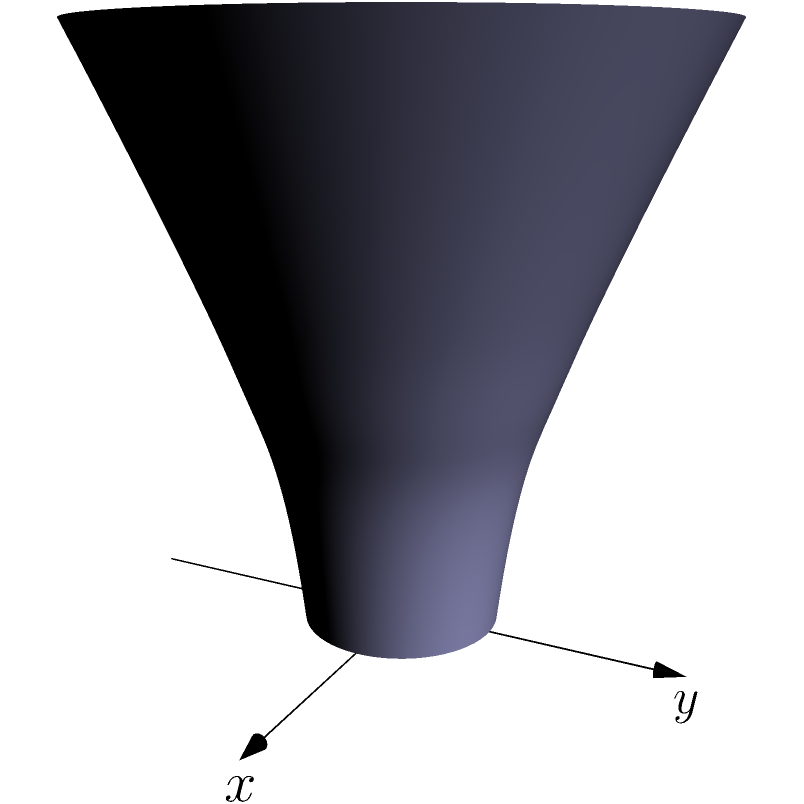Consider the hyperbola $\frac{x^2}{a^2} - \frac{z^2}{b^2} = 1$ in the xz-plane, where $a$ and $b$ are positive constants. When this hyperbola is rotated around the z-axis (its transverse axis), it generates a three-dimensional shape. What is the name of this resulting shape, and what is its equation in Cartesian coordinates? Let's approach this step-by-step:

1) The given hyperbola is $\frac{x^2}{a^2} - \frac{z^2}{b^2} = 1$ in the xz-plane.

2) When we rotate this hyperbola around the z-axis, every point $(x, 0, z)$ on the hyperbola traces out a circle in the xy-plane.

3) The radius of this circle at any given z will be the x-coordinate of the hyperbola at that z.

4) In the xy-plane, the equation of a circle with radius $r$ is $x^2 + y^2 = r^2$.

5) Substituting this into our original hyperbola equation:

   $\frac{(x^2 + y^2)}{a^2} - \frac{z^2}{b^2} = 1$

6) This is the equation of the three-dimensional shape in Cartesian coordinates.

7) This shape is called a hyperboloid of revolution of one sheet, or simply a one-sheet hyperboloid.

8) It's "of revolution" because it's formed by rotating a 2D shape, and "one sheet" because the resulting surface is connected (as opposed to a two-sheet hyperboloid, which would be formed by rotating the other branch of the hyperbola).
Answer: One-sheet hyperboloid; $\frac{x^2 + y^2}{a^2} - \frac{z^2}{b^2} = 1$ 